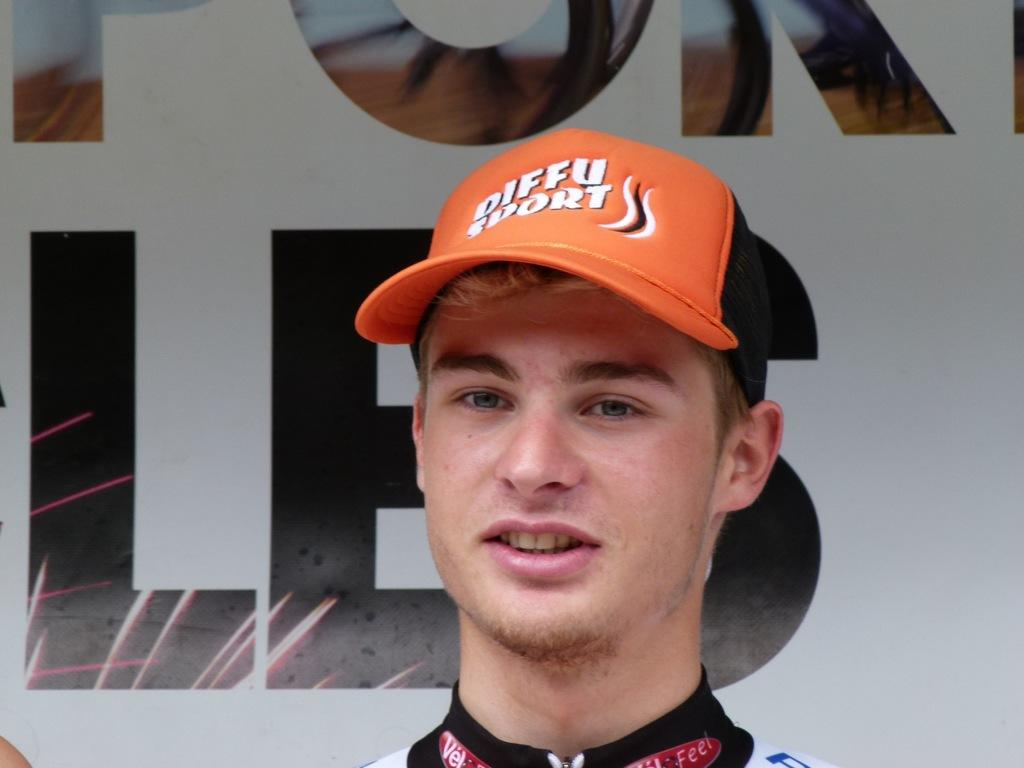<image>
Share a concise interpretation of the image provided. A guy is wearing a Diffu Sport hat in orange and black. 